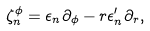<formula> <loc_0><loc_0><loc_500><loc_500>\zeta ^ { \phi } _ { n } = \epsilon _ { n } \partial _ { \phi } - r \epsilon _ { n } ^ { \prime } \partial _ { r } ,</formula> 